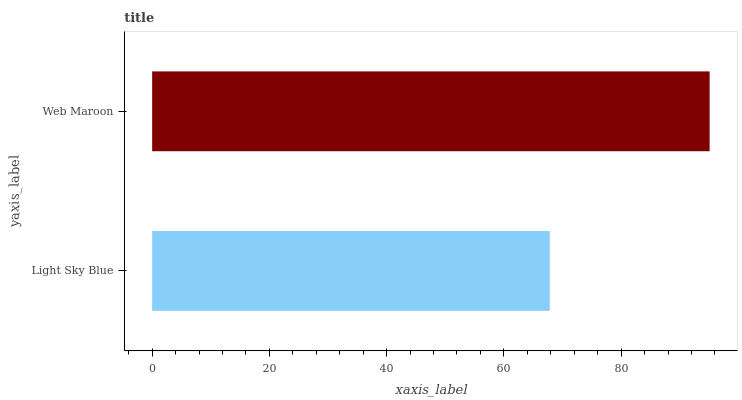Is Light Sky Blue the minimum?
Answer yes or no. Yes. Is Web Maroon the maximum?
Answer yes or no. Yes. Is Web Maroon the minimum?
Answer yes or no. No. Is Web Maroon greater than Light Sky Blue?
Answer yes or no. Yes. Is Light Sky Blue less than Web Maroon?
Answer yes or no. Yes. Is Light Sky Blue greater than Web Maroon?
Answer yes or no. No. Is Web Maroon less than Light Sky Blue?
Answer yes or no. No. Is Web Maroon the high median?
Answer yes or no. Yes. Is Light Sky Blue the low median?
Answer yes or no. Yes. Is Light Sky Blue the high median?
Answer yes or no. No. Is Web Maroon the low median?
Answer yes or no. No. 